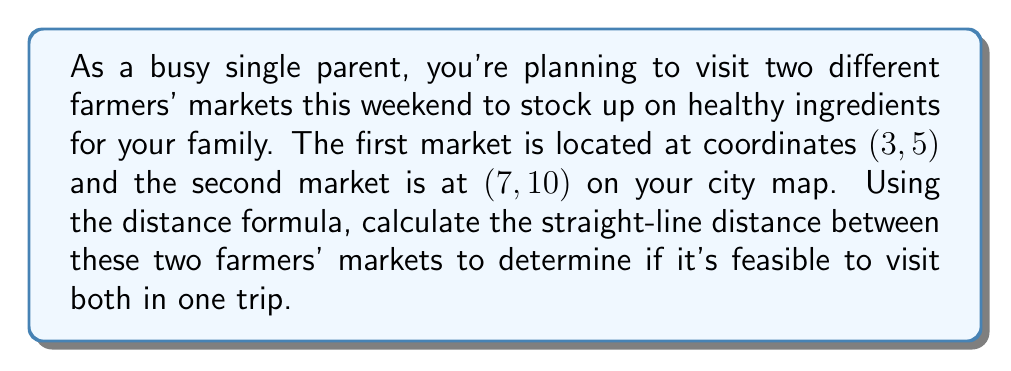Teach me how to tackle this problem. To solve this problem, we'll use the distance formula, which is derived from the Pythagorean theorem. The distance formula for two points $(x_1, y_1)$ and $(x_2, y_2)$ is:

$$d = \sqrt{(x_2 - x_1)^2 + (y_2 - y_1)^2}$$

Let's plug in our coordinates:
- Market 1: $(x_1, y_1) = (3, 5)$
- Market 2: $(x_2, y_2) = (7, 10)$

Now, let's calculate step-by-step:

1. Calculate the differences:
   $x_2 - x_1 = 7 - 3 = 4$
   $y_2 - y_1 = 10 - 5 = 5$

2. Square these differences:
   $(x_2 - x_1)^2 = 4^2 = 16$
   $(y_2 - y_1)^2 = 5^2 = 25$

3. Add the squared differences:
   $16 + 25 = 41$

4. Take the square root of the sum:
   $d = \sqrt{41}$

The exact distance is $\sqrt{41}$ units. If we want to express this as a decimal, we can use a calculator to find that $\sqrt{41} \approx 6.40$ units.

[asy]
unitsize(1cm);
defaultpen(fontsize(10pt));
pair A = (3,5);
pair B = (7,10);
dot(A);
dot(B);
draw(A--B, arrow=Arrow(TeXHead));
label("Market 1 (3,5)", A, SW);
label("Market 2 (7,10)", B, NE);
label("$\sqrt{41}$", (5,7.5), SE);
xaxis(0,8,arrow=Arrow(TeXHead));
yaxis(0,11,arrow=Arrow(TeXHead));
[/asy]
Answer: The distance between the two farmers' markets is $\sqrt{41}$ units (approximately 6.40 units). 